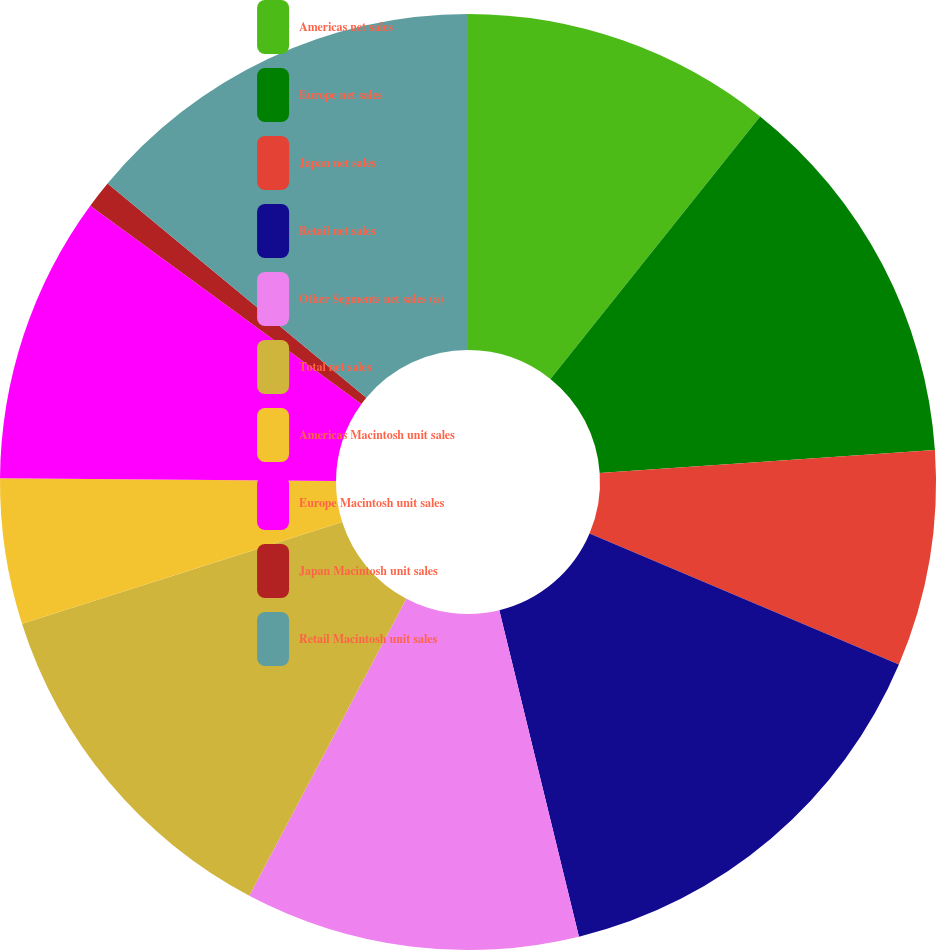Convert chart. <chart><loc_0><loc_0><loc_500><loc_500><pie_chart><fcel>Americas net sales<fcel>Europe net sales<fcel>Japan net sales<fcel>Retail net sales<fcel>Other Segments net sales (a)<fcel>Total net sales<fcel>Americas Macintosh unit sales<fcel>Europe Macintosh unit sales<fcel>Japan Macintosh unit sales<fcel>Retail Macintosh unit sales<nl><fcel>10.73%<fcel>13.18%<fcel>7.47%<fcel>14.81%<fcel>11.55%<fcel>12.36%<fcel>5.03%<fcel>9.92%<fcel>0.96%<fcel>13.99%<nl></chart> 